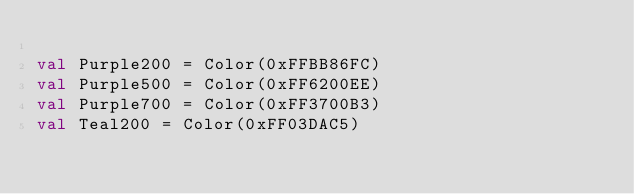Convert code to text. <code><loc_0><loc_0><loc_500><loc_500><_Kotlin_>
val Purple200 = Color(0xFFBB86FC)
val Purple500 = Color(0xFF6200EE)
val Purple700 = Color(0xFF3700B3)
val Teal200 = Color(0xFF03DAC5)</code> 